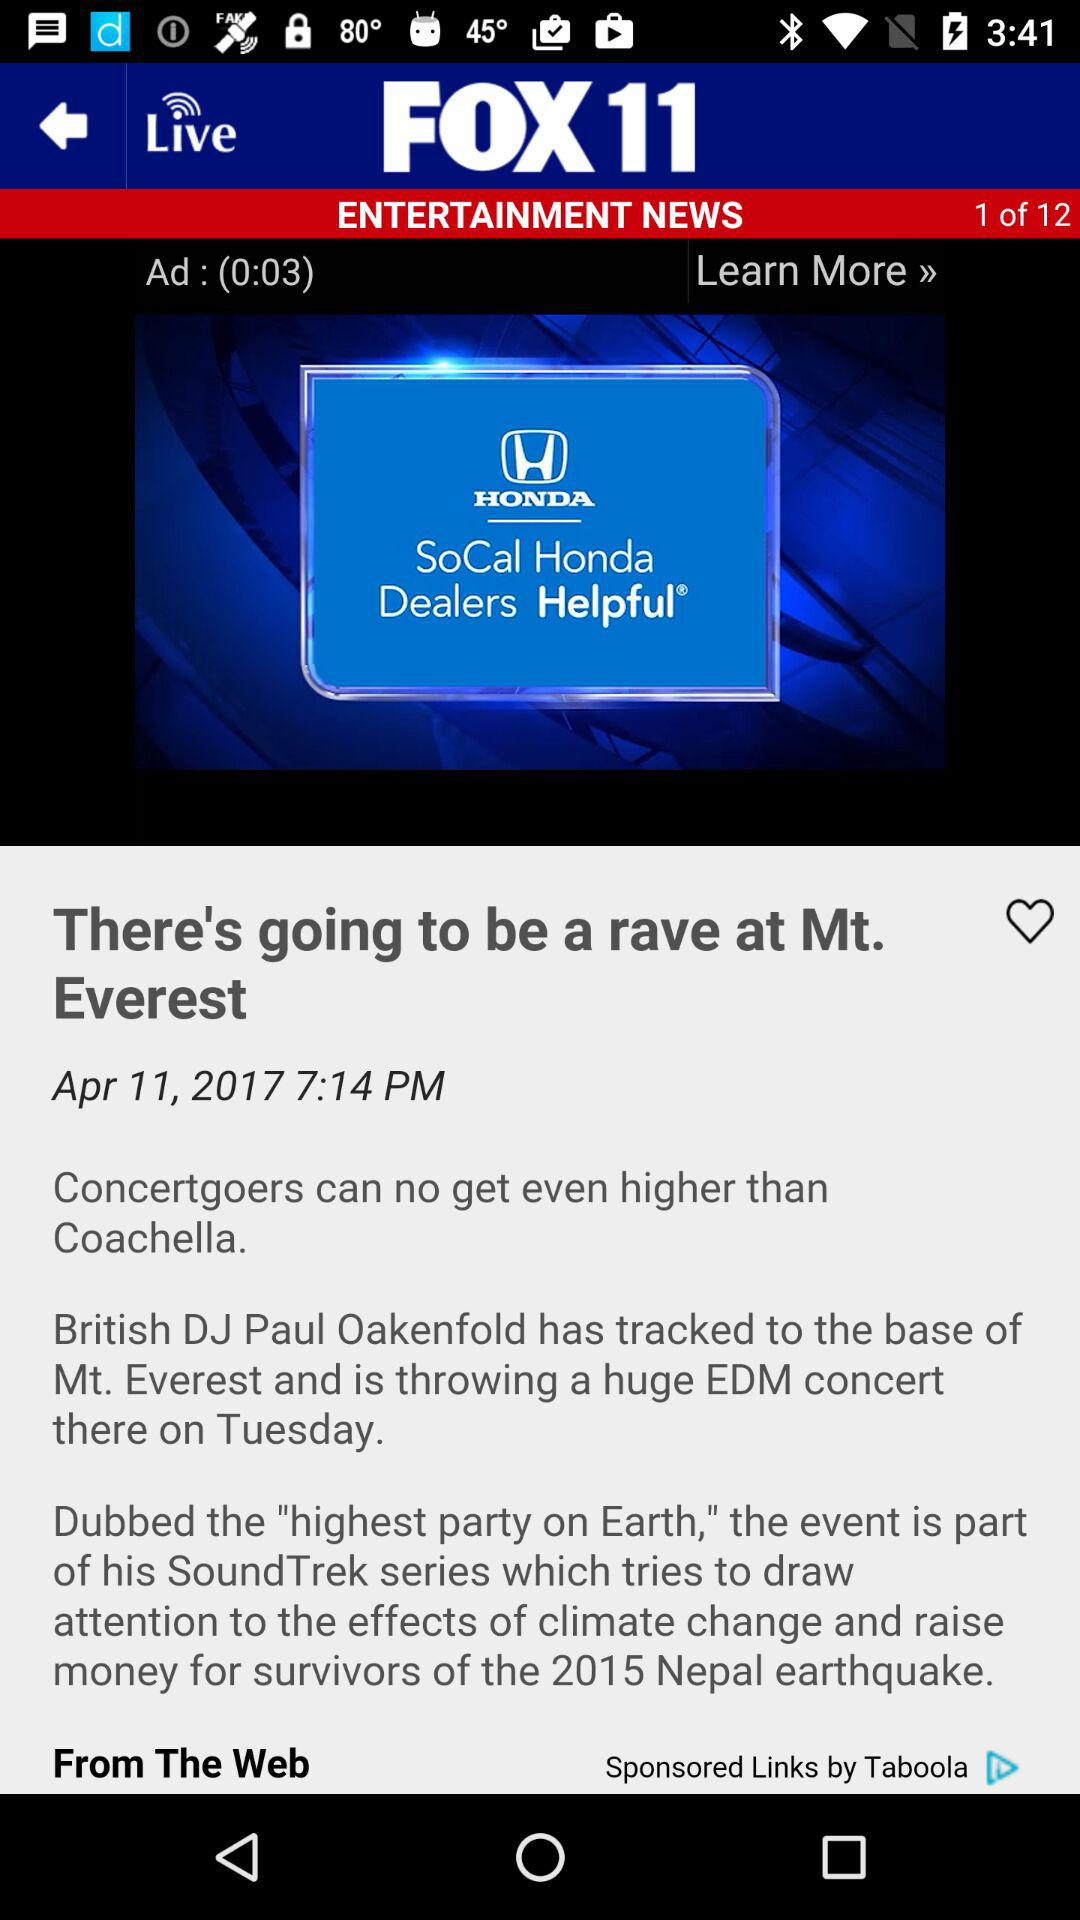On what date is this news updated? This news is updated on April 11, 2017. 